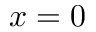Convert formula to latex. <formula><loc_0><loc_0><loc_500><loc_500>x = 0</formula> 